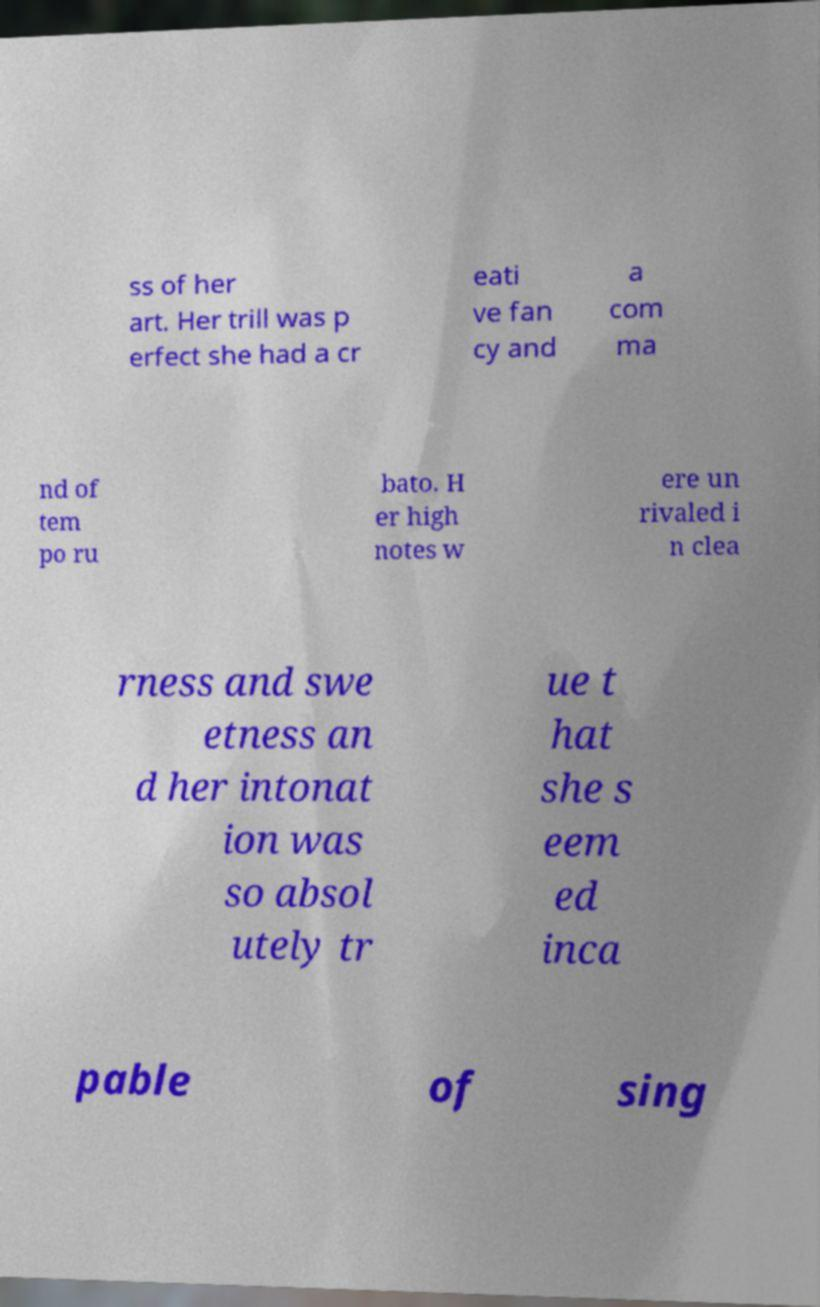Please read and relay the text visible in this image. What does it say? ss of her art. Her trill was p erfect she had a cr eati ve fan cy and a com ma nd of tem po ru bato. H er high notes w ere un rivaled i n clea rness and swe etness an d her intonat ion was so absol utely tr ue t hat she s eem ed inca pable of sing 